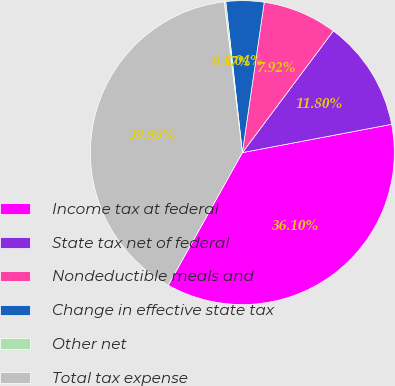<chart> <loc_0><loc_0><loc_500><loc_500><pie_chart><fcel>Income tax at federal<fcel>State tax net of federal<fcel>Nondeductible meals and<fcel>Change in effective state tax<fcel>Other net<fcel>Total tax expense<nl><fcel>36.1%<fcel>11.8%<fcel>7.92%<fcel>4.04%<fcel>0.17%<fcel>39.98%<nl></chart> 